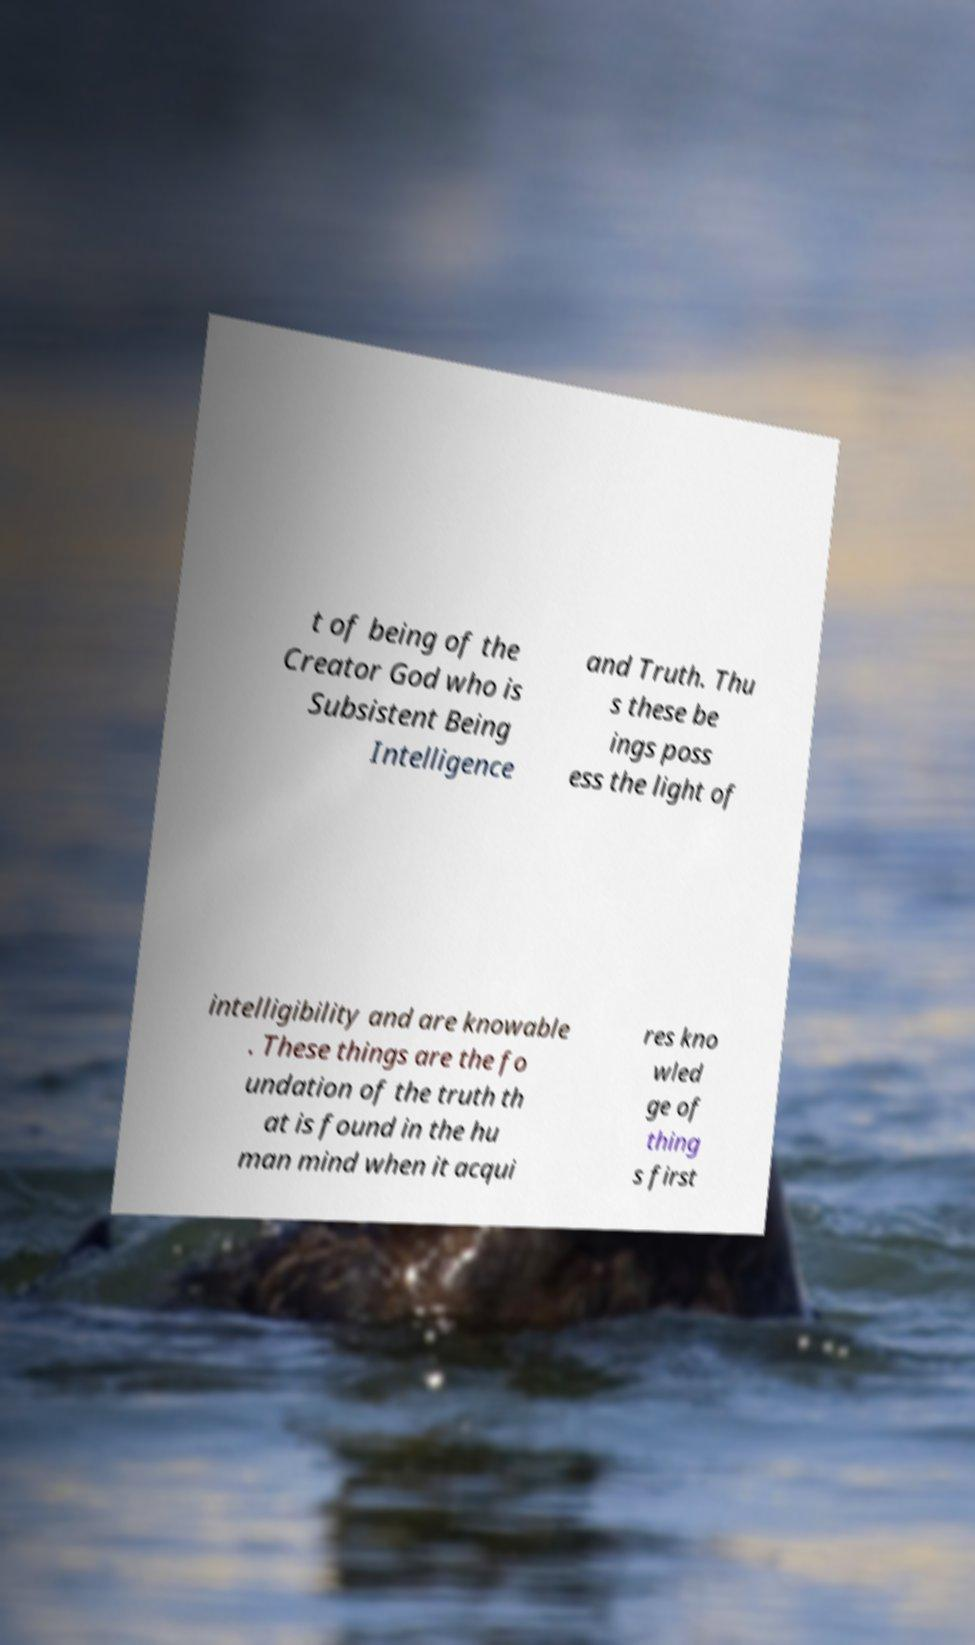Can you read and provide the text displayed in the image?This photo seems to have some interesting text. Can you extract and type it out for me? t of being of the Creator God who is Subsistent Being Intelligence and Truth. Thu s these be ings poss ess the light of intelligibility and are knowable . These things are the fo undation of the truth th at is found in the hu man mind when it acqui res kno wled ge of thing s first 